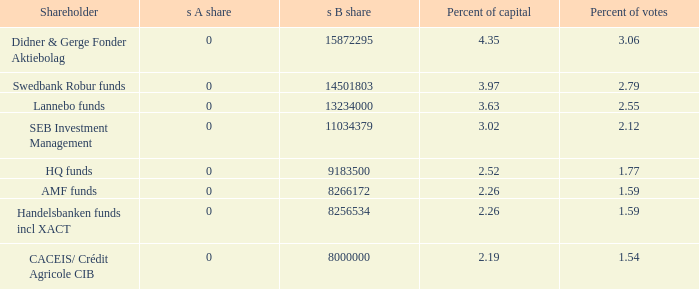What is the s b share for the stockholder with 11034379.0. 